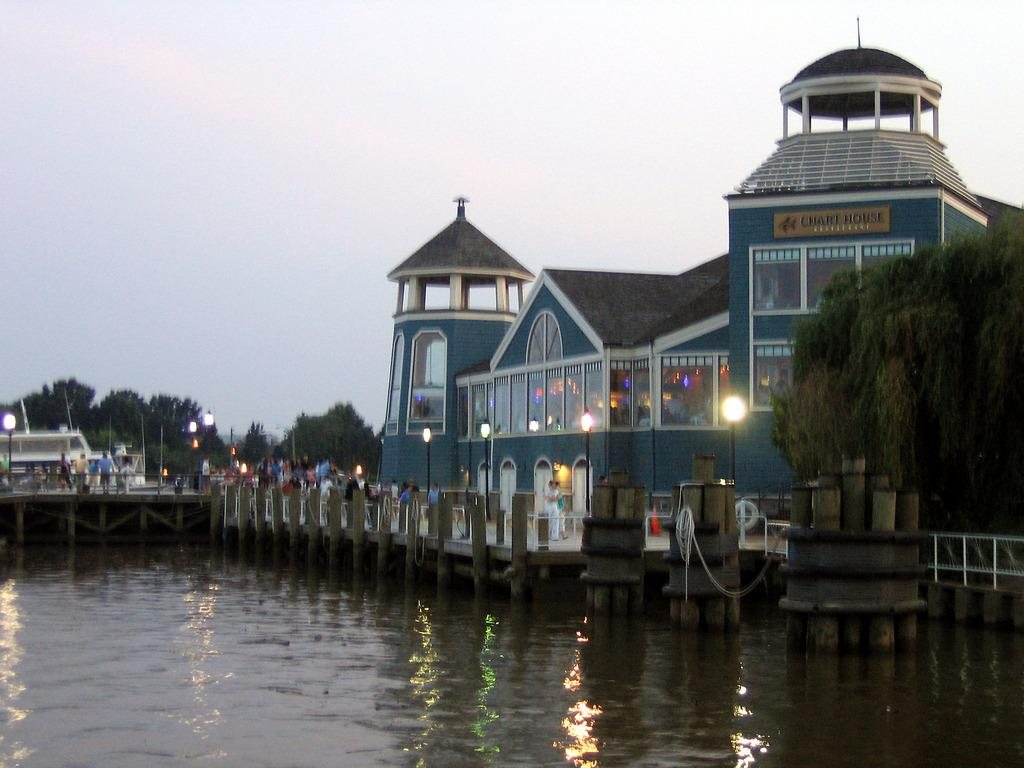<image>
Present a compact description of the photo's key features. A large building with Chart House on top of it. 